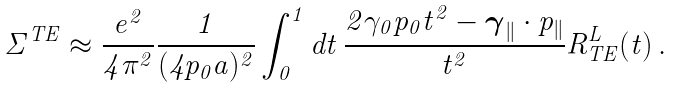Convert formula to latex. <formula><loc_0><loc_0><loc_500><loc_500>\Sigma ^ { T E } \approx \frac { e ^ { 2 } } { 4 \pi ^ { 2 } } \frac { 1 } { ( 4 p _ { 0 } a ) ^ { 2 } } \int _ { 0 } ^ { 1 } d t \, \frac { 2 \gamma _ { 0 } p _ { 0 } t ^ { 2 } - \boldsymbol \gamma _ { \| } \cdot { p } _ { \| } } { t ^ { 2 } } R ^ { L } _ { T E } ( t ) \, .</formula> 